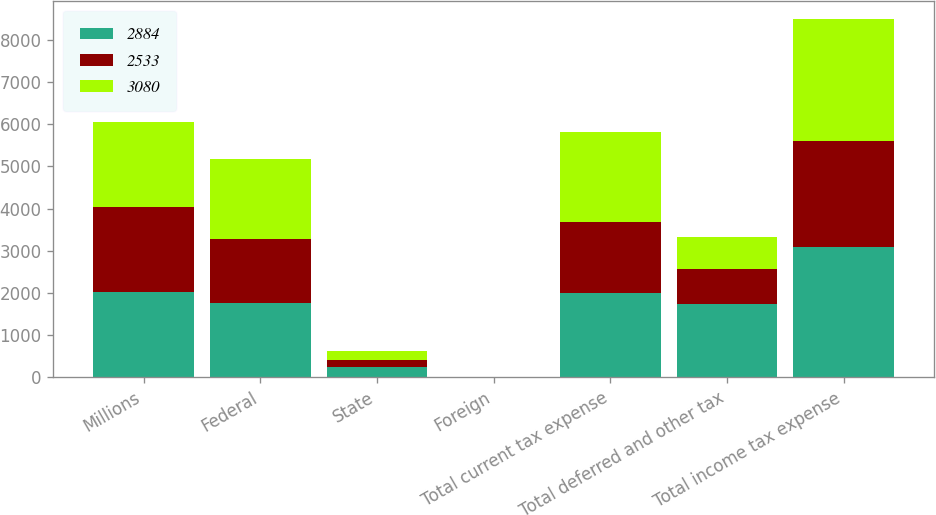<chart> <loc_0><loc_0><loc_500><loc_500><stacked_bar_chart><ecel><fcel>Millions<fcel>Federal<fcel>State<fcel>Foreign<fcel>Total current tax expense<fcel>Total deferred and other tax<fcel>Total income tax expense<nl><fcel>2884<fcel>2017<fcel>1750<fcel>235<fcel>2<fcel>1987<fcel>1726<fcel>3080<nl><fcel>2533<fcel>2016<fcel>1518<fcel>176<fcel>8<fcel>1702<fcel>831<fcel>2533<nl><fcel>3080<fcel>2015<fcel>1901<fcel>210<fcel>8<fcel>2119<fcel>765<fcel>2884<nl></chart> 